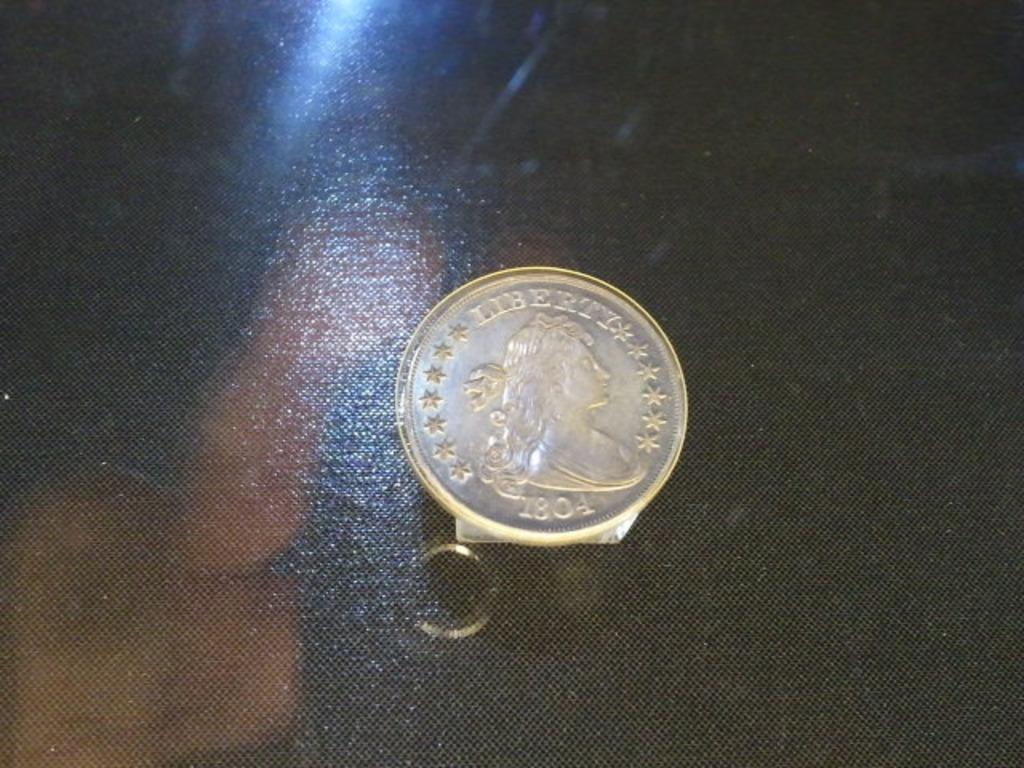What year is the coin from?
Your answer should be compact. 1804. What does the coin say at the top?
Offer a terse response. Liberty. 